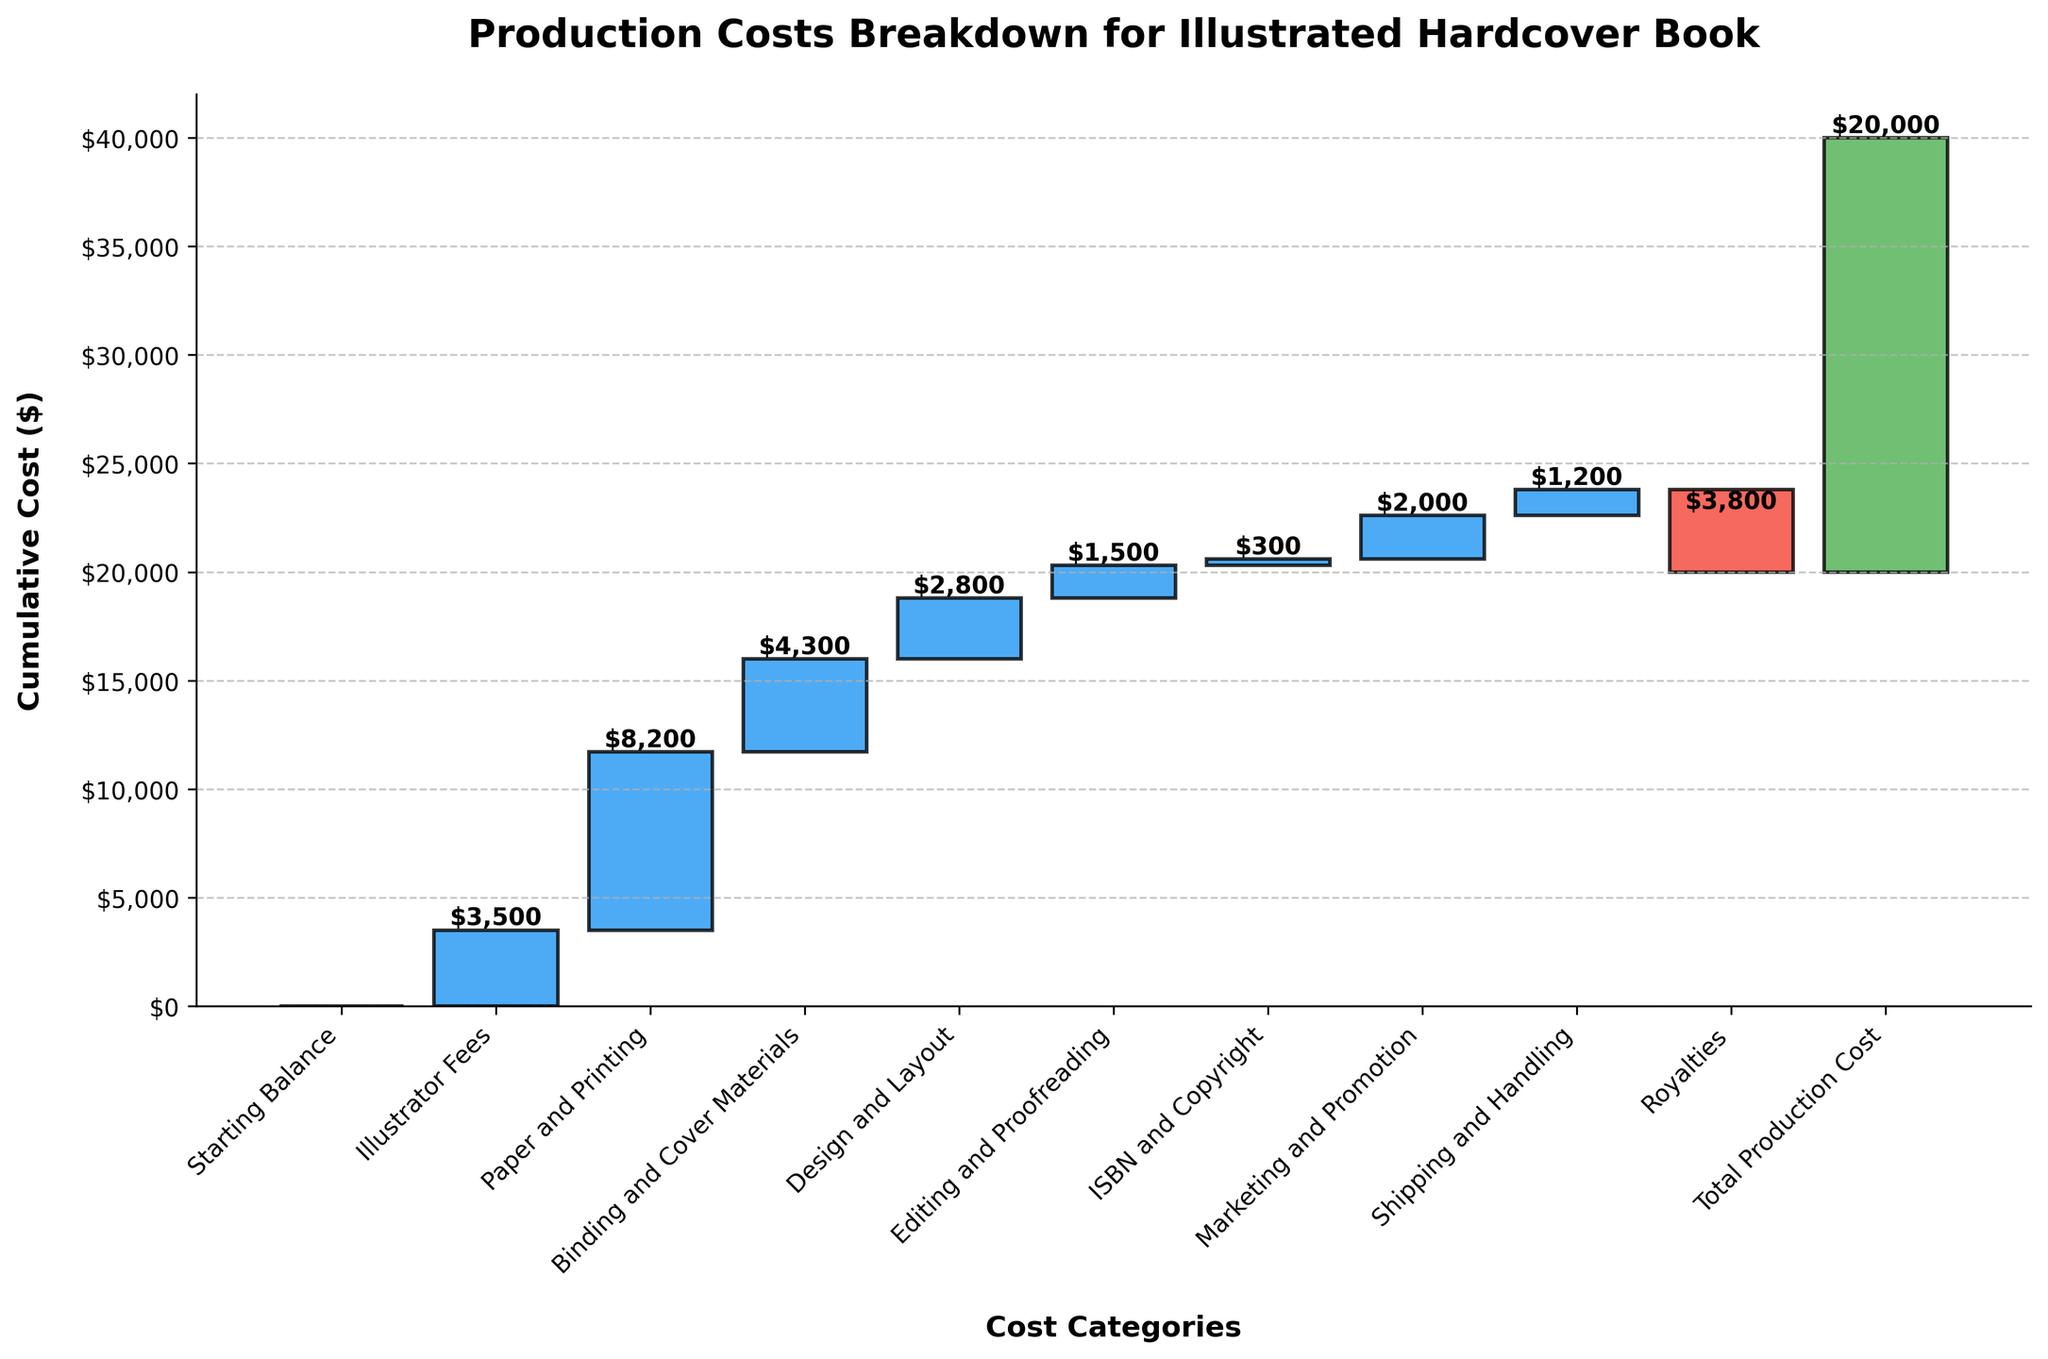What is the title of the figure? The title of a figure is usually displayed at the top and gives a summary of what the figure is about.
Answer: Production Costs Breakdown for Illustrated Hardcover Book What is the total production cost? The total production cost is displayed as the last category bar in the waterfall chart. This bar typically summarizes all the previous categories.
Answer: $20,000 Which cost category has the highest value? To determine the highest value, look at the heights of the different bars. The tallest positive value bar represents the highest cost category. Here, "Paper and Printing" stands out as the tallest.
Answer: Paper and Printing What is the value of the Illustrator Fees? Find the bar labeled "Illustrator Fees" and read off the value next to it.
Answer: $3,500 How much is spent on Shipping and Handling? To find this, locate the bar labeled "Shipping and Handling" and note the value shown.
Answer: $1,200 Which category reduces the total cost? In a waterfall chart, categories that decrease the total cost are shown with bars going downward. The only negative cost here is "Royalties".
Answer: Royalties What is the cumulative cost after Design and Layout? The cumulative cost after "Design and Layout" includes the cumulative sum starting from "Starting Balance" through "Design and Layout". Calculation: 0 + 3,500 + 8,200 + 4,300 + 2,800 = 18,800
Answer: $18,800 By how much does Marketing and Promotion increase the total cost? Identify the bar for "Marketing and Promotion" and note its value. This value shows the direct increment to the total cost.
Answer: $2,000 Which categories contribute less than $2,000? Identify the values for each category and filter out those which are less than $2,000. The relevant categories are "Editing and Proofreading", "ISBN and Copyright", "Shipping and Handling", and "Marketing and Promotion".
Answer: Editing and Proofreading, ISBN and Copyright, Shipping and Handling What is the difference between Paper and Printing costs and Binding and Cover Materials costs? Deduct the cost of Binding and Cover Materials from the cost of Paper and Printing. Calculation: 8,200 - 4,300 = 3,900
Answer: $3,900 